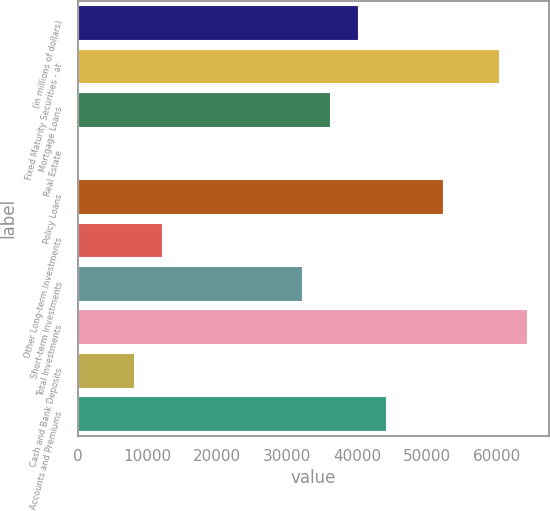Convert chart to OTSL. <chart><loc_0><loc_0><loc_500><loc_500><bar_chart><fcel>(in millions of dollars)<fcel>Fixed Maturity Securities - at<fcel>Mortgage Loans<fcel>Real Estate<fcel>Policy Loans<fcel>Other Long-term Investments<fcel>Short-term Investments<fcel>Total Investments<fcel>Cash and Bank Deposits<fcel>Accounts and Premiums<nl><fcel>40163.3<fcel>60236<fcel>36148.8<fcel>17.9<fcel>52206.9<fcel>12061.5<fcel>32134.2<fcel>64250.5<fcel>8046.98<fcel>44177.8<nl></chart> 